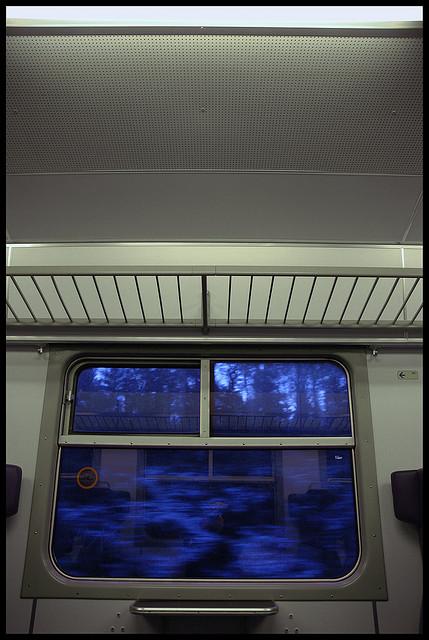Is the train moving?
Quick response, please. Yes. Where are the plains located?
Write a very short answer. Outside. What is the color of the window?
Be succinct. Clear. What is above the window?
Keep it brief. Shelf. Where was the picture taken?
Write a very short answer. Train. 